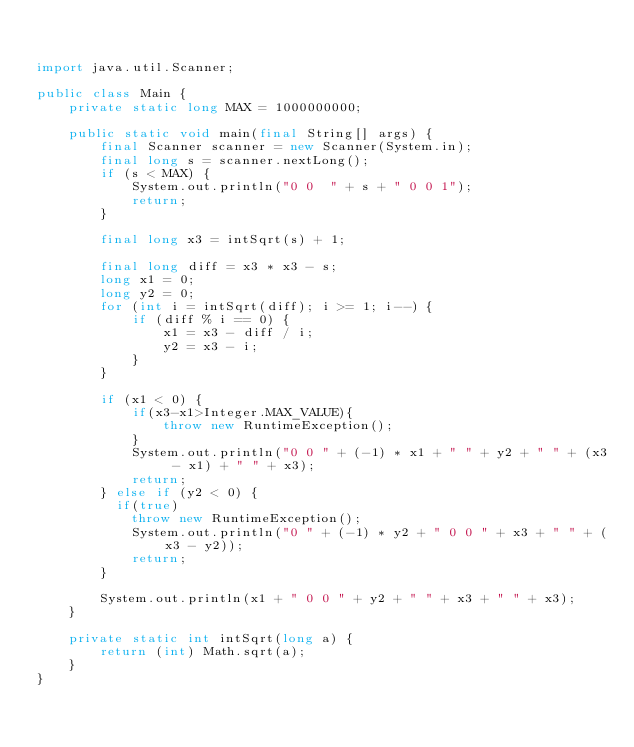Convert code to text. <code><loc_0><loc_0><loc_500><loc_500><_Java_>

import java.util.Scanner;

public class Main {
    private static long MAX = 1000000000;

    public static void main(final String[] args) {
        final Scanner scanner = new Scanner(System.in);
        final long s = scanner.nextLong();
        if (s < MAX) {
            System.out.println("0 0  " + s + " 0 0 1");
            return;
        }

        final long x3 = intSqrt(s) + 1;

        final long diff = x3 * x3 - s;
        long x1 = 0;
        long y2 = 0;
        for (int i = intSqrt(diff); i >= 1; i--) {
            if (diff % i == 0) {
                x1 = x3 - diff / i;
                y2 = x3 - i;
            }
        }

        if (x1 < 0) {
            if(x3-x1>Integer.MAX_VALUE){
                throw new RuntimeException();
            }
            System.out.println("0 0 " + (-1) * x1 + " " + y2 + " " + (x3 - x1) + " " + x3);
            return;
        } else if (y2 < 0) {
          if(true)
            throw new RuntimeException();
            System.out.println("0 " + (-1) * y2 + " 0 0 " + x3 + " " + (x3 - y2));
            return;
        }

        System.out.println(x1 + " 0 0 " + y2 + " " + x3 + " " + x3);
    }

    private static int intSqrt(long a) {
        return (int) Math.sqrt(a);
    }
}
</code> 